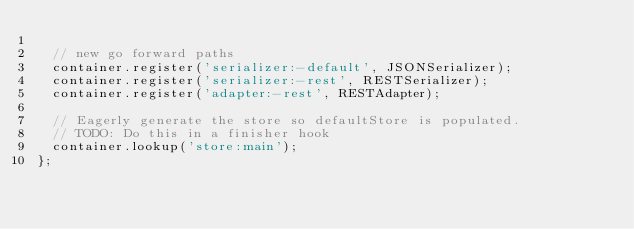<code> <loc_0><loc_0><loc_500><loc_500><_JavaScript_>
  // new go forward paths
  container.register('serializer:-default', JSONSerializer);
  container.register('serializer:-rest', RESTSerializer);
  container.register('adapter:-rest', RESTAdapter);

  // Eagerly generate the store so defaultStore is populated.
  // TODO: Do this in a finisher hook
  container.lookup('store:main');
};
</code> 